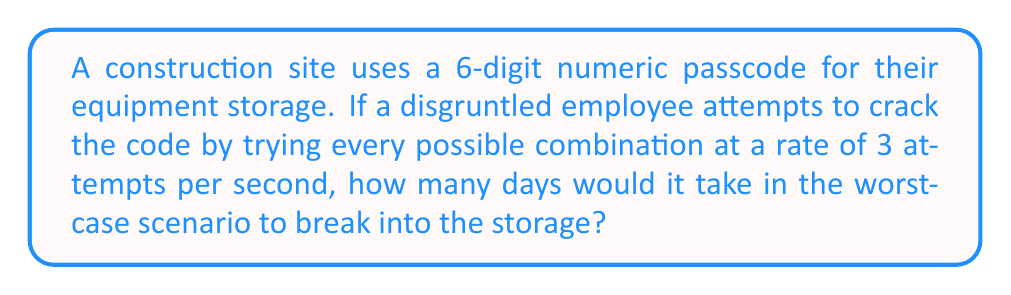Teach me how to tackle this problem. Let's approach this step-by-step:

1) First, we need to calculate the total number of possible combinations:
   - The passcode is 6 digits long
   - Each digit can be any number from 0 to 9
   - So, the total number of combinations is $10^6 = 1,000,000$

2) Now, we need to calculate how many attempts can be made per day:
   - The employee can make 3 attempts per second
   - In one minute, that's $3 * 60 = 180$ attempts
   - In one hour, that's $180 * 60 = 10,800$ attempts
   - In one day, that's $10,800 * 24 = 259,200$ attempts

3) To find the number of days, we divide the total number of combinations by the number of attempts per day:

   $$\text{Days} = \frac{\text{Total combinations}}{\text{Attempts per day}} = \frac{1,000,000}{259,200} \approx 3.858$$

4) Rounding up to the nearest whole day (since we're considering the worst-case scenario), we get 4 days.
Answer: 4 days 